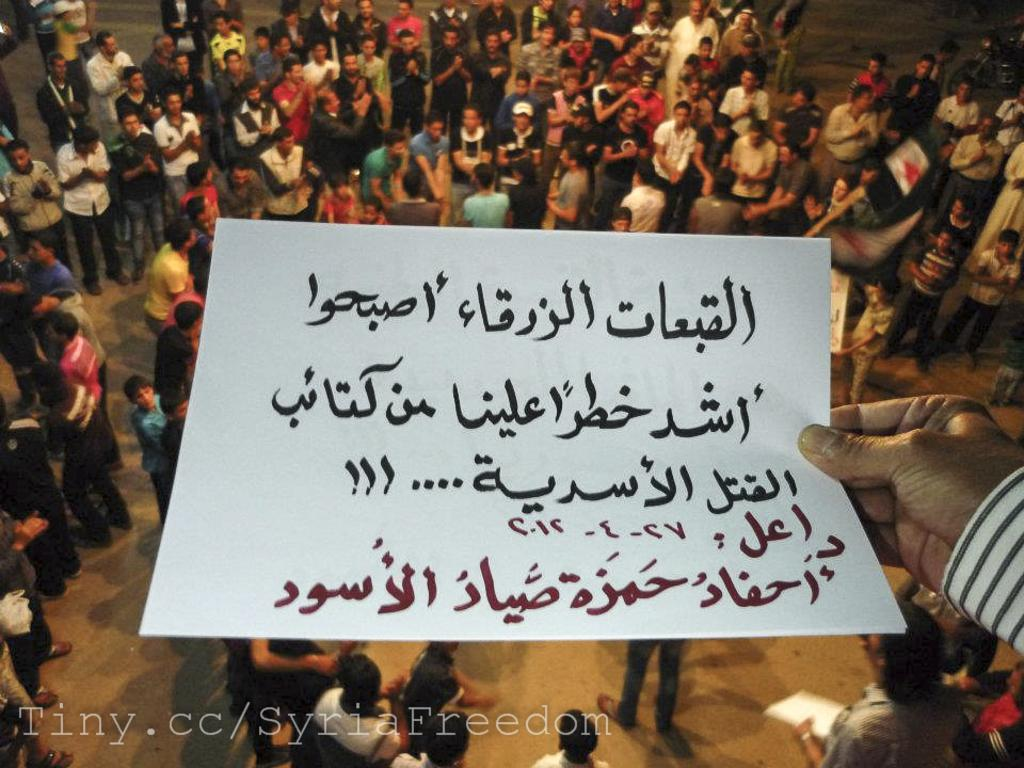What is the main subject of the image? The main subject of the image is a group of people. Can you describe the action of one of the individuals in the group? Yes, there is a person holding a paper in the image. What can be said about the color of the paper being held? The paper is white in color. What type of lumber is being used to build the house in the image? There is no house or lumber present in the image; it features a group of people and a person holding a white paper. 